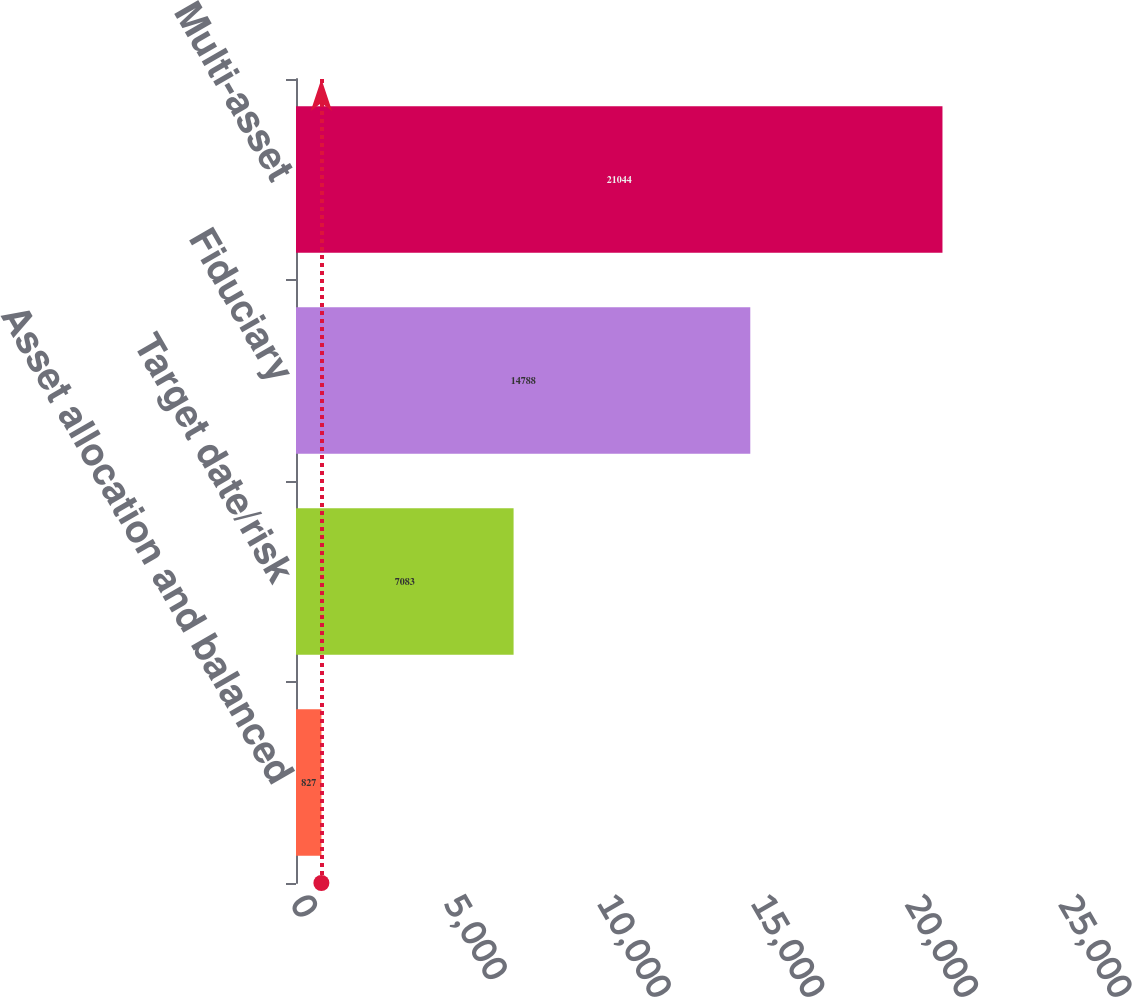<chart> <loc_0><loc_0><loc_500><loc_500><bar_chart><fcel>Asset allocation and balanced<fcel>Target date/risk<fcel>Fiduciary<fcel>Multi-asset<nl><fcel>827<fcel>7083<fcel>14788<fcel>21044<nl></chart> 